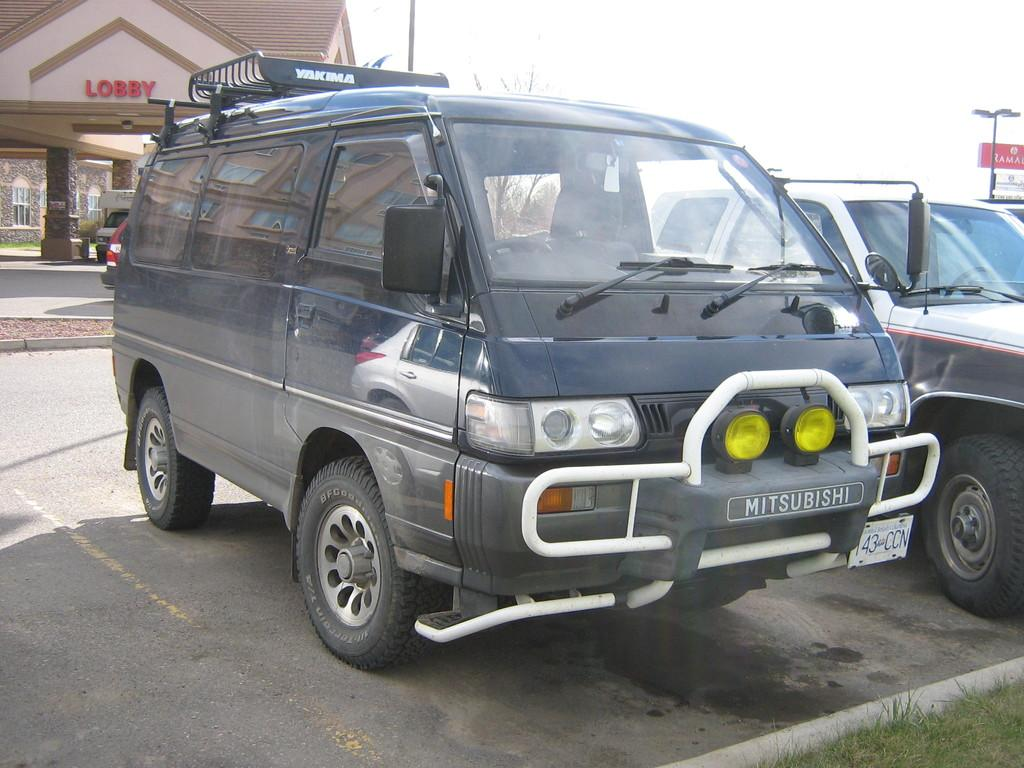What can be seen on the road in the image? There are vehicles on the road in the image. What type of structure is present in the image? There is a house in the image. What type of vegetation is visible in the image? There is grass in the image. What type of plant is present in the image? There is a tree in the image. What architectural feature can be seen in the image? There are pillars in the image. What type of signage is present in the image? There is a board with text in the image. What part of the natural environment is visible in the image? The sky is visible in the image. What type of man-made structure is present in the image? There is a light pole in the image. How many hens are sitting on the roof of the house in the image? There are no hens present in the image; only vehicles, a house, grass, a tree, pillars, a board with text, the sky, and a light pole can be seen. 